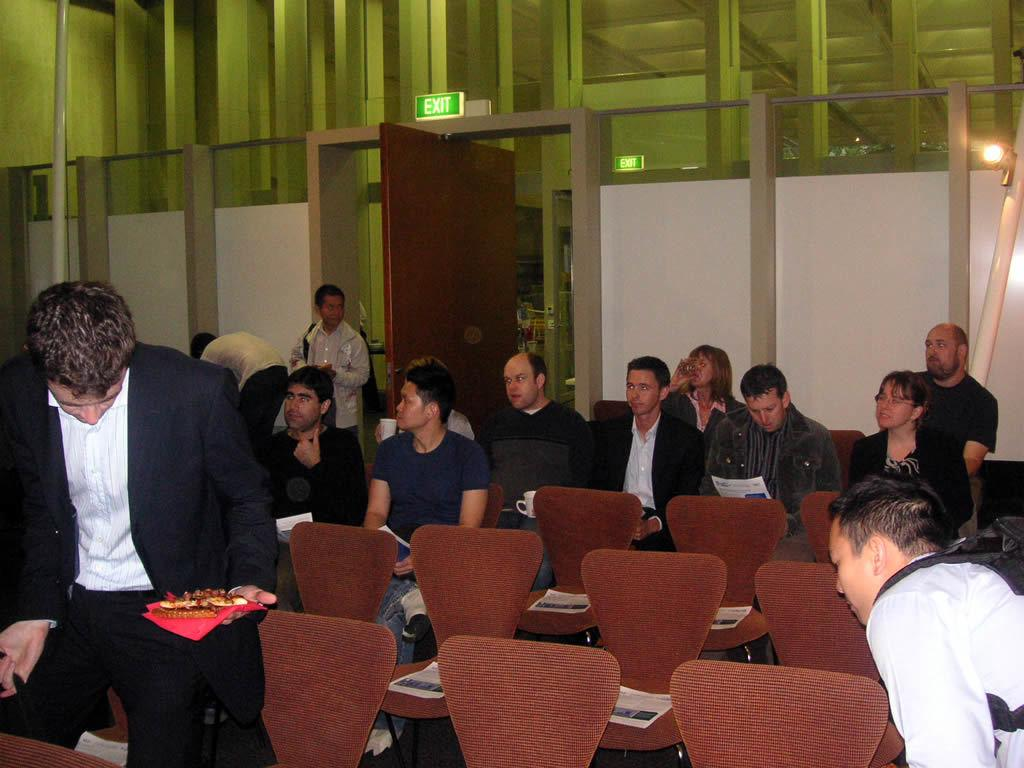What are the people in the image doing? There are persons sitting on chairs and standing in the image. What is on the chairs? Papers are present on the chairs. What can be seen in the background of the image? There is a wall, lights, and a board in the background. Who is holding food in the image? A person is holding food in the image. Can you see a donkey swinging on a request in the image? No, there is no donkey, swing, or request present in the image. 